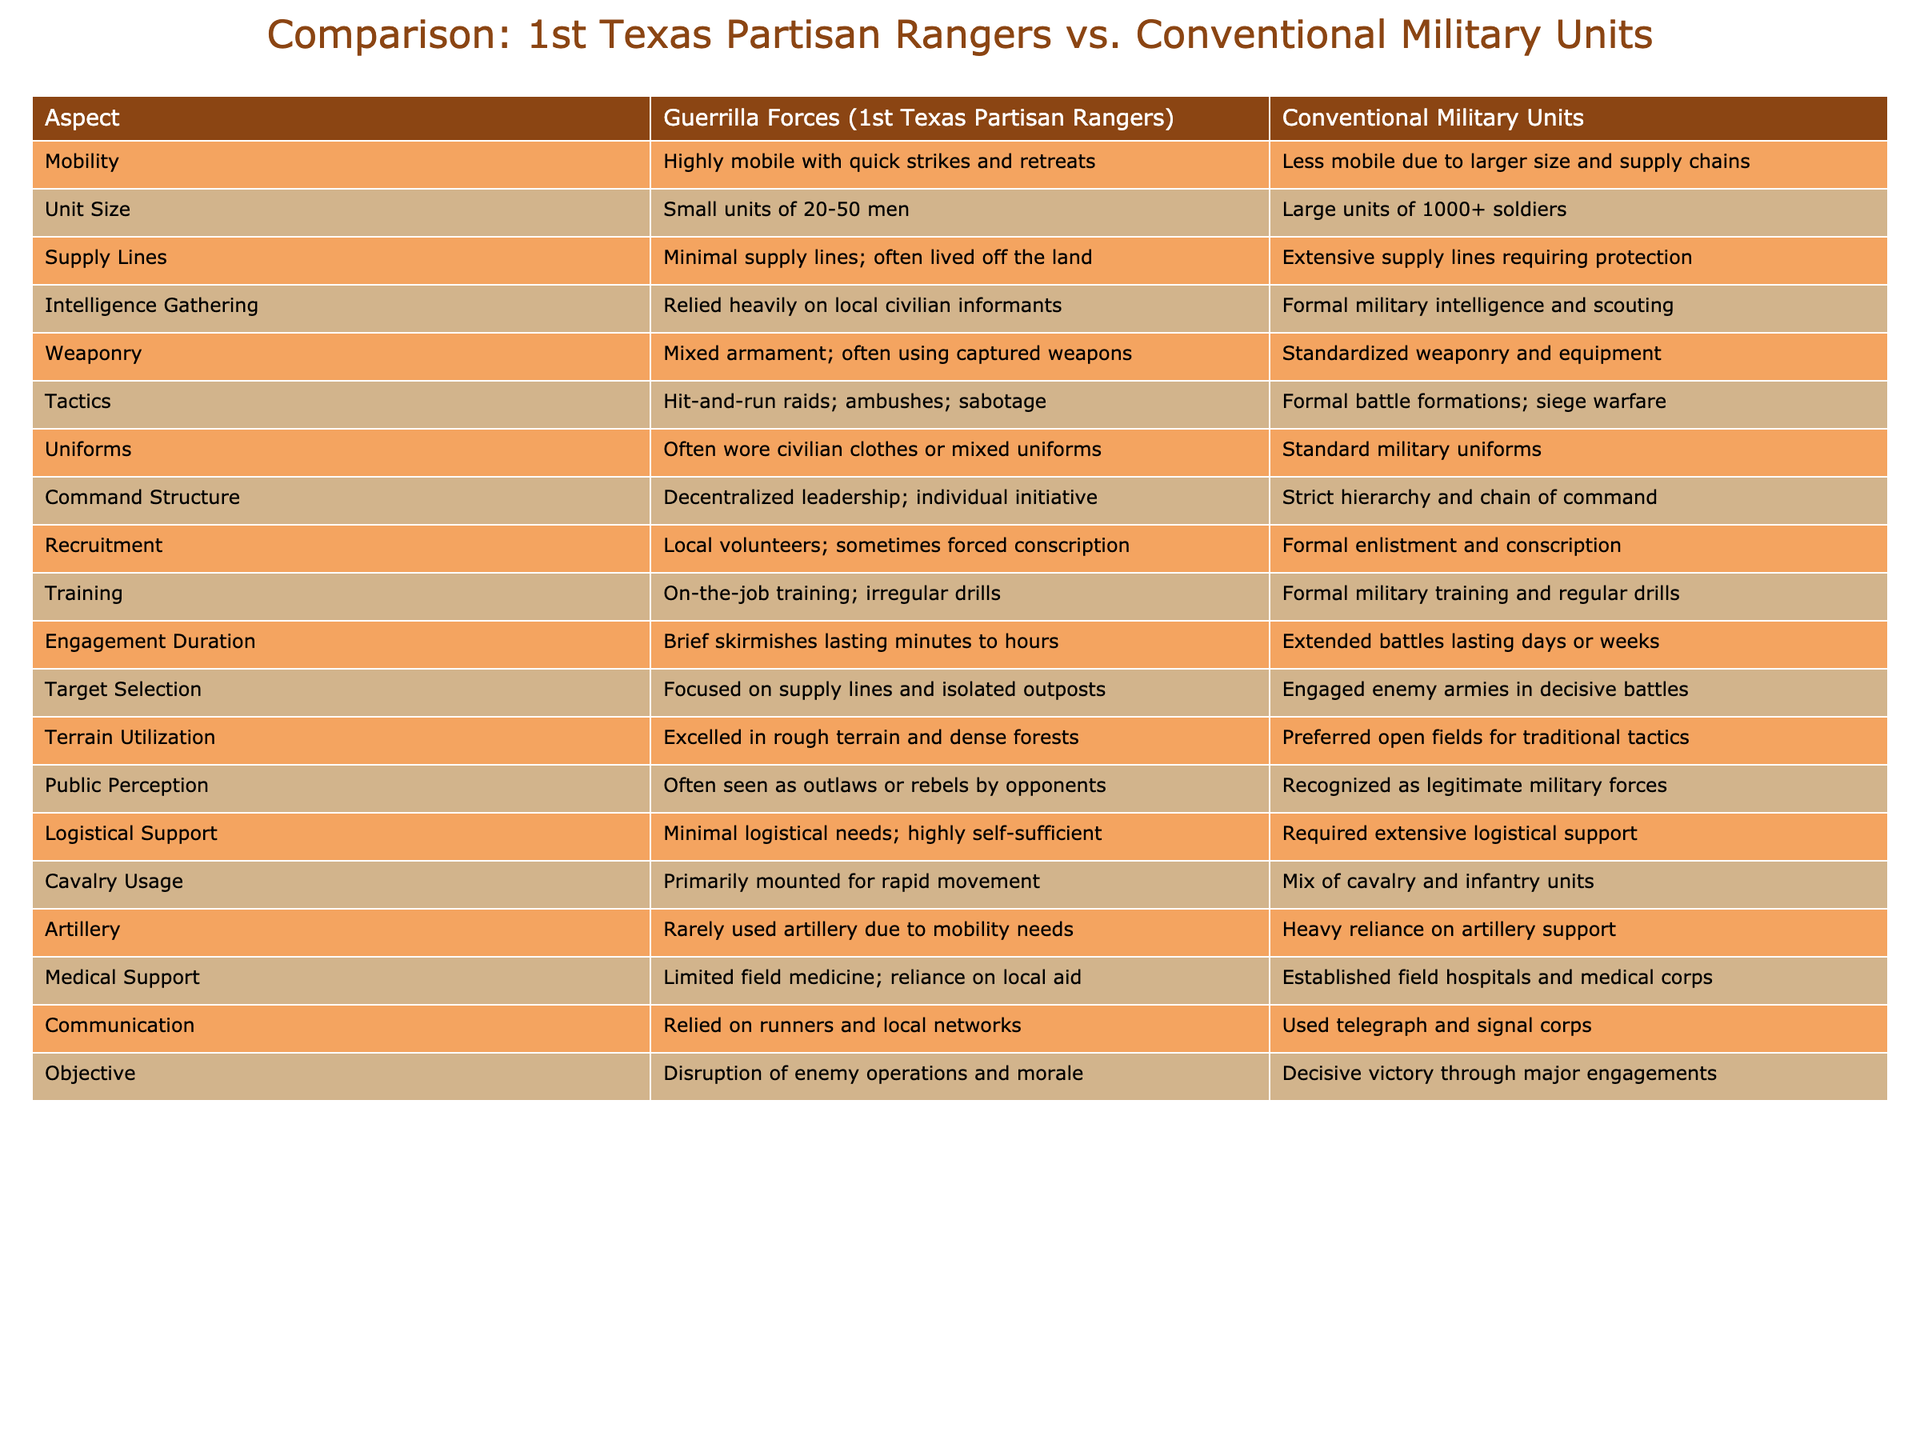What is the mobility difference between guerrilla forces and conventional military units? The table shows that guerrilla forces, represented by the 1st Texas Partisan Rangers, are highly mobile with quick strikes and retreats, while conventional military units are less mobile due to their larger size and supply chains.
Answer: Highly mobile vs. less mobile Which type of unit has a larger size? According to the table, conventional military units are large, typically consisting of 1000 or more soldiers, whereas guerrilla forces consist of smaller units of 20 to 50 men.
Answer: Conventional military units Do guerrilla forces rely on formal military intelligence? The data indicates that guerrilla forces rely heavily on local civilian informants for intelligence gathering, as opposed to conventional military units, which use formal military intelligence and scouting. Thus, the answer is no.
Answer: No What are the primary tactics used by guerrilla forces? The table states that guerrilla forces primarily employ hit-and-run raids, ambushes, and sabotage as their tactics, differentiating them from conventional military units that use formal battle formations and siege warfare.
Answer: Hit-and-run raids, ambushes, sabotage Is there a significant difference between guerrilla forces and conventional military units regarding uniforms? Yes, guerrilla forces often wear civilian clothes or mixed uniforms, while conventional military units are characterized by standardized military uniforms. Therefore, the answer is yes.
Answer: Yes Which type of unit utilizes cavalry more effectively? The table reflects that guerrilla forces primarily use mounted units for rapid movement, while conventional military units utilize a mix of cavalry and infantry. Clearly, guerrilla forces are more effective in cavalry usage due to their emphasis on mobility.
Answer: Guerrilla forces How does the engagement duration of guerrilla forces differ from that of conventional military units? The table outlines that guerrilla forces tend to engage in brief skirmishes lasting minutes to hours, while conventional military units often participate in extended battles lasting days or weeks, indicating a clear difference in engagement duration.
Answer: Brief skirmishes vs. extended battles What is the level of medical support available to guerrilla forces compared to conventional military units? The table notes that guerrilla forces have limited field medicine and rely on local aid, while conventional military units have established field hospitals and medical corps, demonstrating a significant difference in medical support capacity.
Answer: Limited vs. established What target selection strategy is emphasized more by guerrilla forces? Guerrilla forces focus on disrupting enemy operations by targeting supply lines and isolated outposts, whereas conventional military units engage enemy armies in decisive battles. This indicates a distinct strategy difference in target selection.
Answer: Supply lines and isolated outposts 